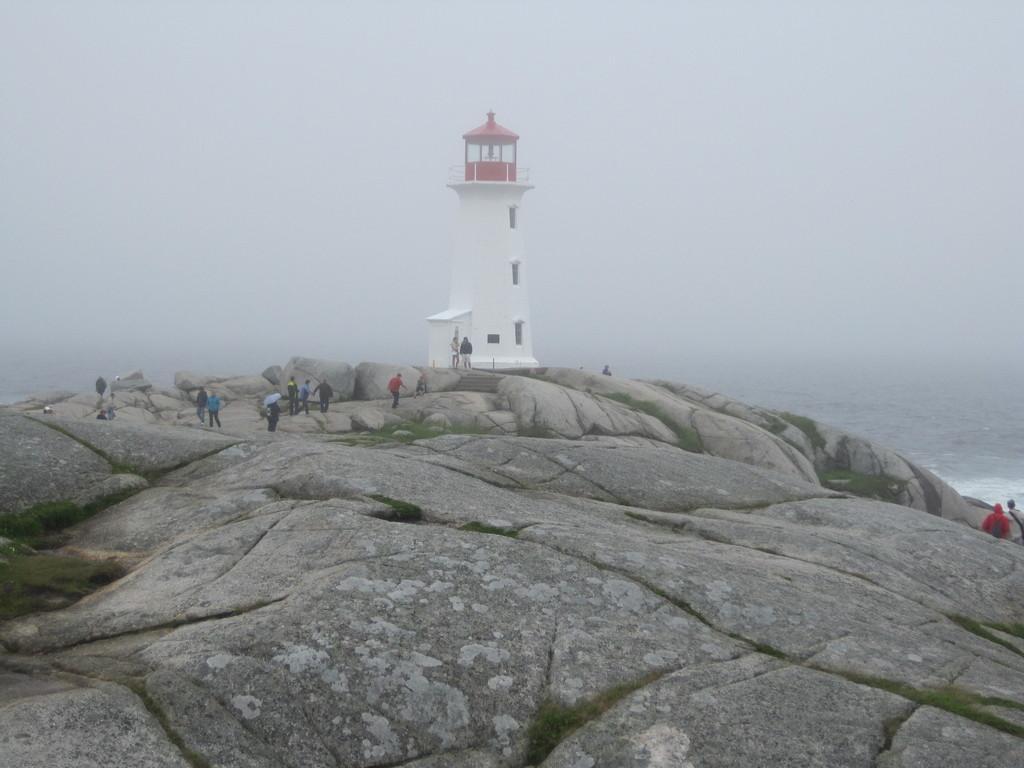How would you summarize this image in a sentence or two? In this image I can see a lighthouse,few people walking. I can see the water,rock and the sky is in white color. 